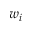<formula> <loc_0><loc_0><loc_500><loc_500>w _ { i }</formula> 